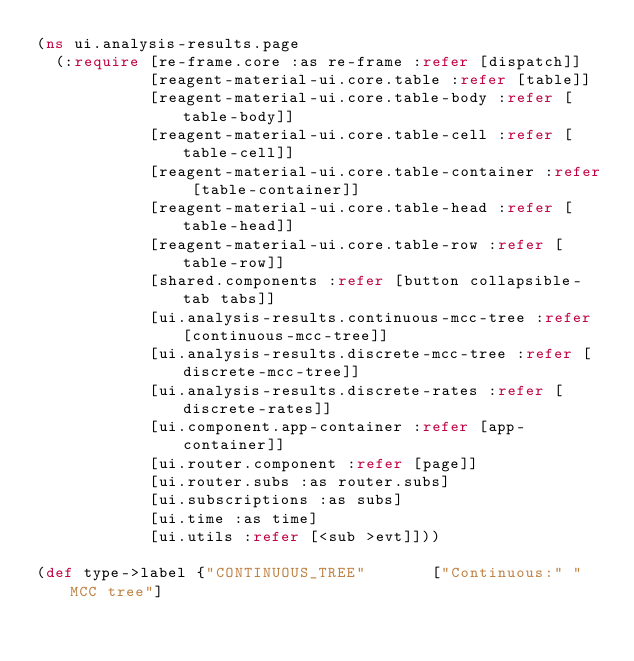Convert code to text. <code><loc_0><loc_0><loc_500><loc_500><_Clojure_>(ns ui.analysis-results.page
  (:require [re-frame.core :as re-frame :refer [dispatch]]
            [reagent-material-ui.core.table :refer [table]]
            [reagent-material-ui.core.table-body :refer [table-body]]
            [reagent-material-ui.core.table-cell :refer [table-cell]]
            [reagent-material-ui.core.table-container :refer [table-container]]
            [reagent-material-ui.core.table-head :refer [table-head]]
            [reagent-material-ui.core.table-row :refer [table-row]]
            [shared.components :refer [button collapsible-tab tabs]]
            [ui.analysis-results.continuous-mcc-tree :refer [continuous-mcc-tree]]
            [ui.analysis-results.discrete-mcc-tree :refer [discrete-mcc-tree]]
            [ui.analysis-results.discrete-rates :refer [discrete-rates]]
            [ui.component.app-container :refer [app-container]]
            [ui.router.component :refer [page]]
            [ui.router.subs :as router.subs]
            [ui.subscriptions :as subs]
            [ui.time :as time]
            [ui.utils :refer [<sub >evt]]))

(def type->label {"CONTINUOUS_TREE"       ["Continuous:" "MCC tree"]</code> 